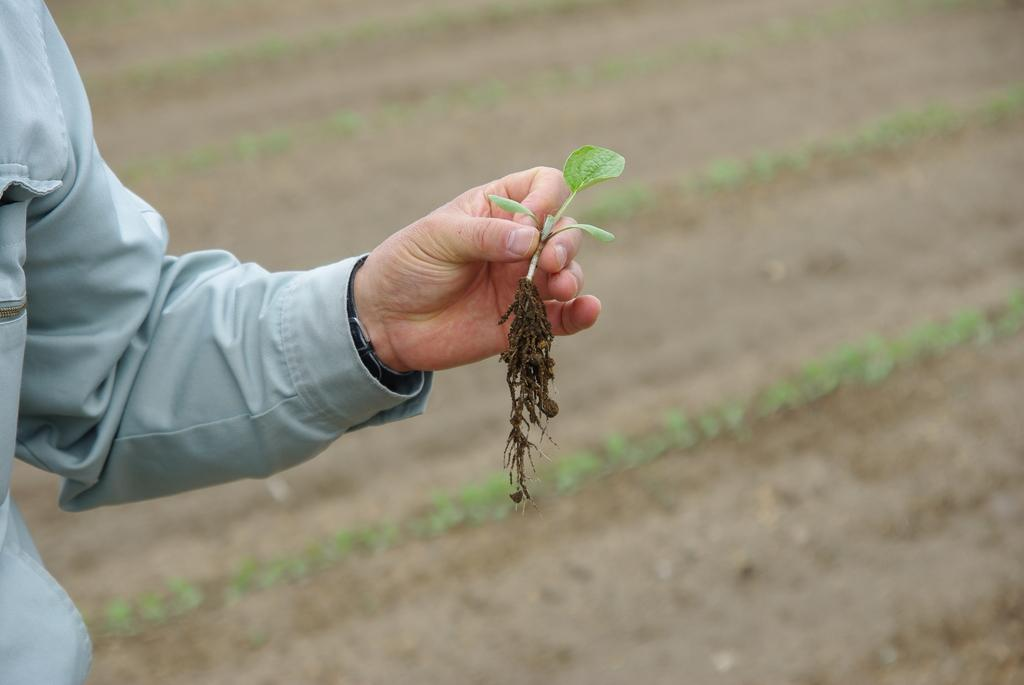What is the main subject of the image? There is a person in the image. What is the person holding in the image? The person is holding a plant. Can you describe the background of the image? The background of the image is blurry. How many waves can be seen in the image? There are no waves present in the image. What type of duck is visible in the image? There are no ducks present in the image. 